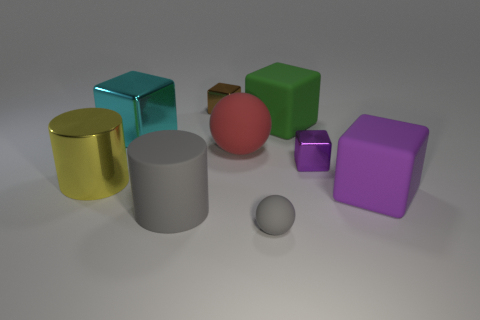Does the tiny rubber thing have the same color as the large rubber cylinder?
Keep it short and to the point. Yes. How many purple blocks are in front of the ball that is in front of the cylinder in front of the big yellow metal cylinder?
Your response must be concise. 0. The gray thing in front of the large cylinder in front of the large purple rubber object is what shape?
Provide a short and direct response. Sphere. The purple matte thing that is the same shape as the tiny purple shiny object is what size?
Offer a terse response. Large. What color is the metal thing to the right of the tiny gray rubber object?
Make the answer very short. Purple. There is a gray object on the left side of the metal object that is behind the big matte block that is behind the purple matte block; what is its material?
Keep it short and to the point. Rubber. There is a purple cube behind the object right of the small purple metal cube; what is its size?
Offer a very short reply. Small. What color is the large shiny thing that is the same shape as the tiny purple metallic thing?
Your answer should be very brief. Cyan. How many cylinders have the same color as the small ball?
Your response must be concise. 1. Is the size of the purple matte block the same as the brown block?
Provide a succinct answer. No. 